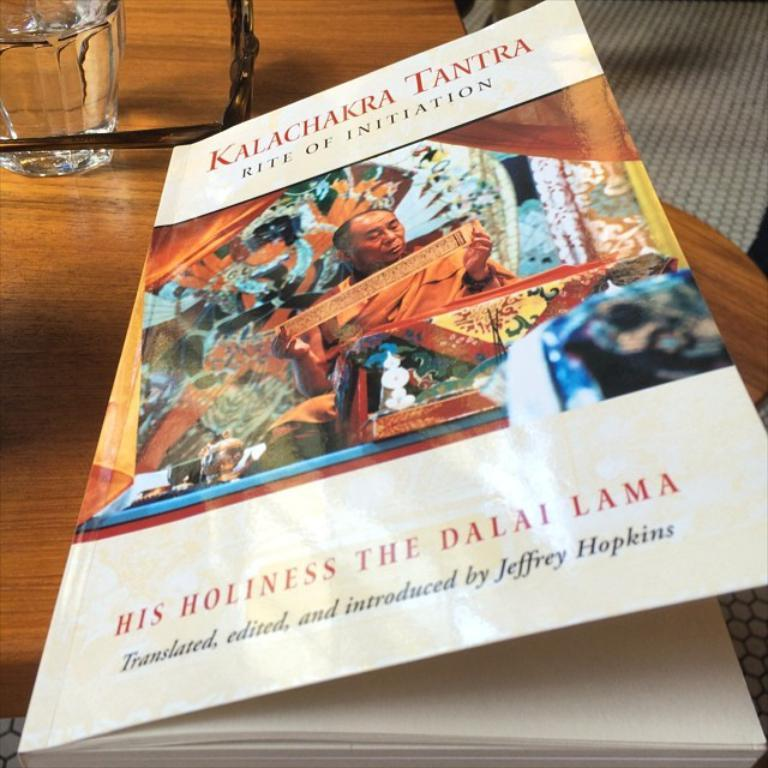<image>
Write a terse but informative summary of the picture. A book that says Kalachakra Tanra is on a wooden table. 